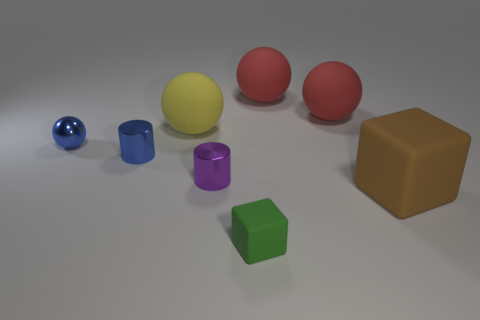Subtract all red spheres. How many were subtracted if there are1red spheres left? 1 Subtract all blue metallic spheres. How many spheres are left? 3 Add 1 green objects. How many objects exist? 9 Subtract all blue spheres. How many spheres are left? 3 Add 2 small metal spheres. How many small metal spheres are left? 3 Add 3 green matte things. How many green matte things exist? 4 Subtract 0 brown cylinders. How many objects are left? 8 Subtract all cylinders. How many objects are left? 6 Subtract 2 blocks. How many blocks are left? 0 Subtract all purple cubes. Subtract all red cylinders. How many cubes are left? 2 